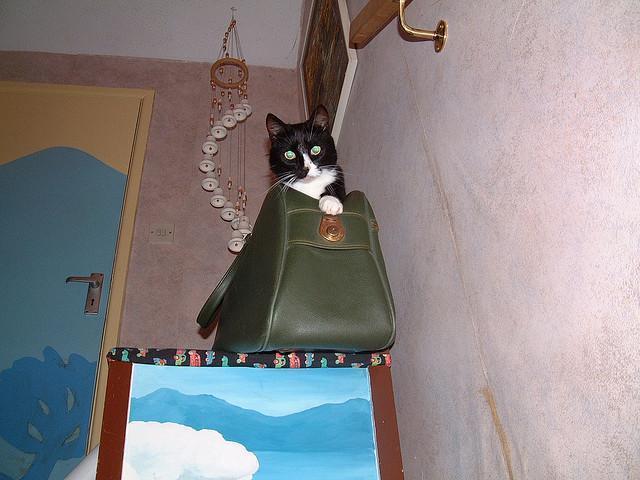How many bikes are there?
Give a very brief answer. 0. 